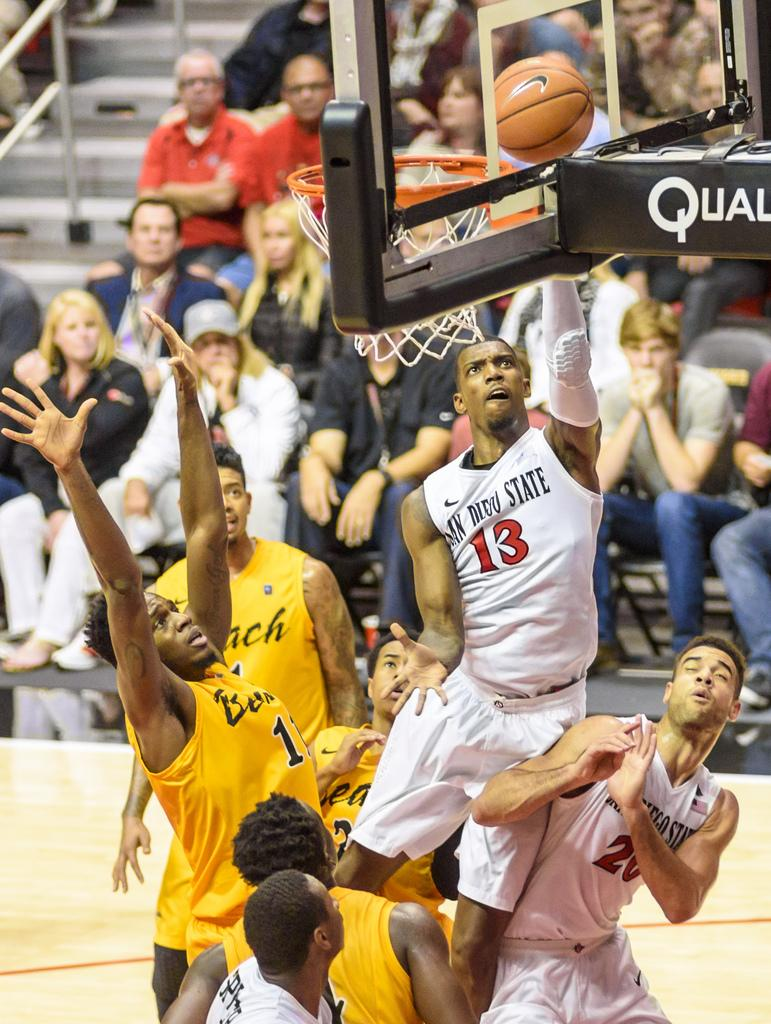Who or what can be seen in the image? There are people in the image. What architectural feature is present in the image? There are stairs in the image. What object is visible that might be used for catching or holding? There is a net in the image. What type of barrier can be seen in the image? There is a wall in the image. Where is the sink located in the image? There is no sink present in the image. What time is displayed on the clock in the image? There is no clock present in the image. 